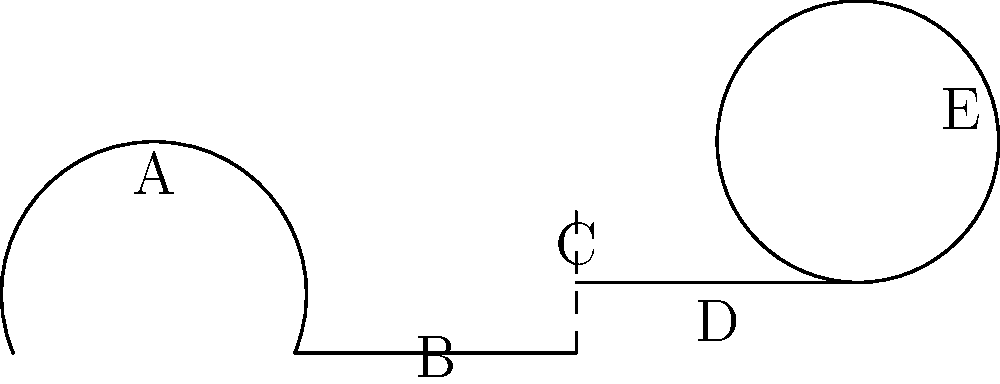Identify the part of the ear labeled "E" in the diagram and explain its primary function in the hearing process. To answer this question, let's analyze the diagram and identify the parts of the ear:

1. Part A represents the outer ear (pinna).
2. Part B is the ear canal.
3. Part C is likely the eardrum (tympanic membrane).
4. Part D represents the middle ear.
5. Part E, which is the focus of our question, is the cochlea.

The cochlea is a spiral-shaped structure in the inner ear. Its primary functions in the hearing process are:

1. Sound wave conversion: The cochlea contains fluid and thousands of tiny hair cells.

2. Mechanical to electrical transduction: When sound waves reach the cochlea, they cause the fluid inside to move, which in turn bends the hair cells.

3. Frequency discrimination: Different parts of the cochlea respond to different frequencies of sound, allowing us to distinguish between various pitches.

4. Neural signaling: The movement of the hair cells triggers the release of neurotransmitters, which stimulate the auditory nerve fibers.

5. Signal transmission: The auditory nerve then carries these electrical signals to the brain for interpretation.

In summary, the cochlea is crucial for converting mechanical sound waves into electrical signals that the brain can interpret as sound.
Answer: Cochlea; converts sound waves into electrical signals for the brain to interpret 